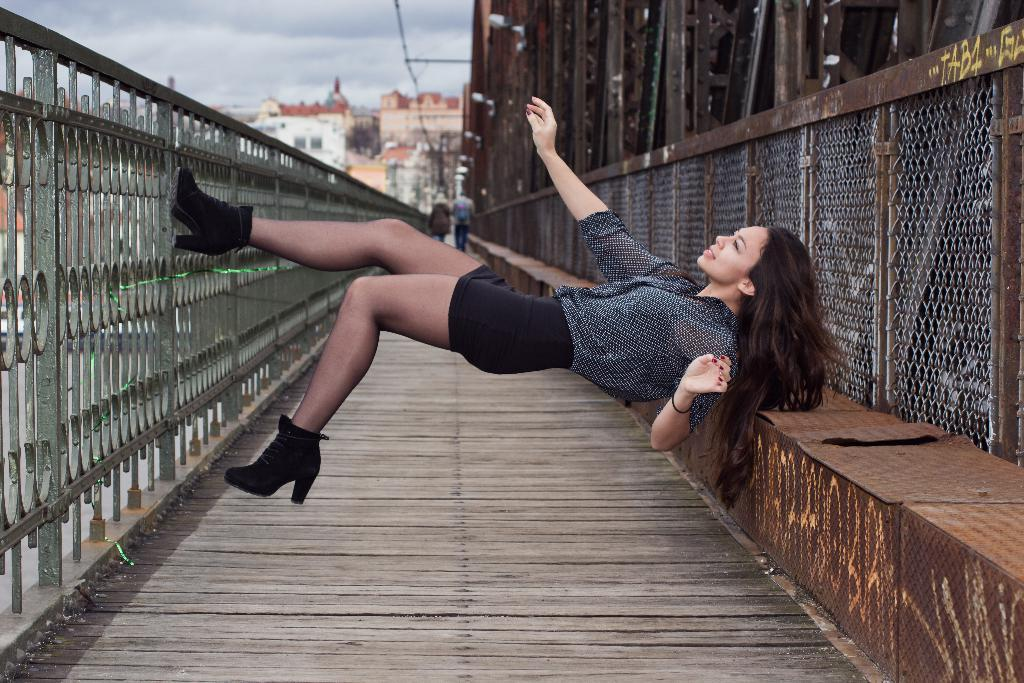Who is the main subject in the image? There is a woman in the center of the image. What can be seen in the background of the image? There are buildings in the background of the image. How would you describe the weather based on the image? The sky is cloudy in the image. What is located on the left side of the image? There is a fence on the left side of the image. Where is the rabbit hiding in the image? There is no rabbit present in the image. What type of root can be seen growing near the fence in the image? There are no roots visible in the image. 